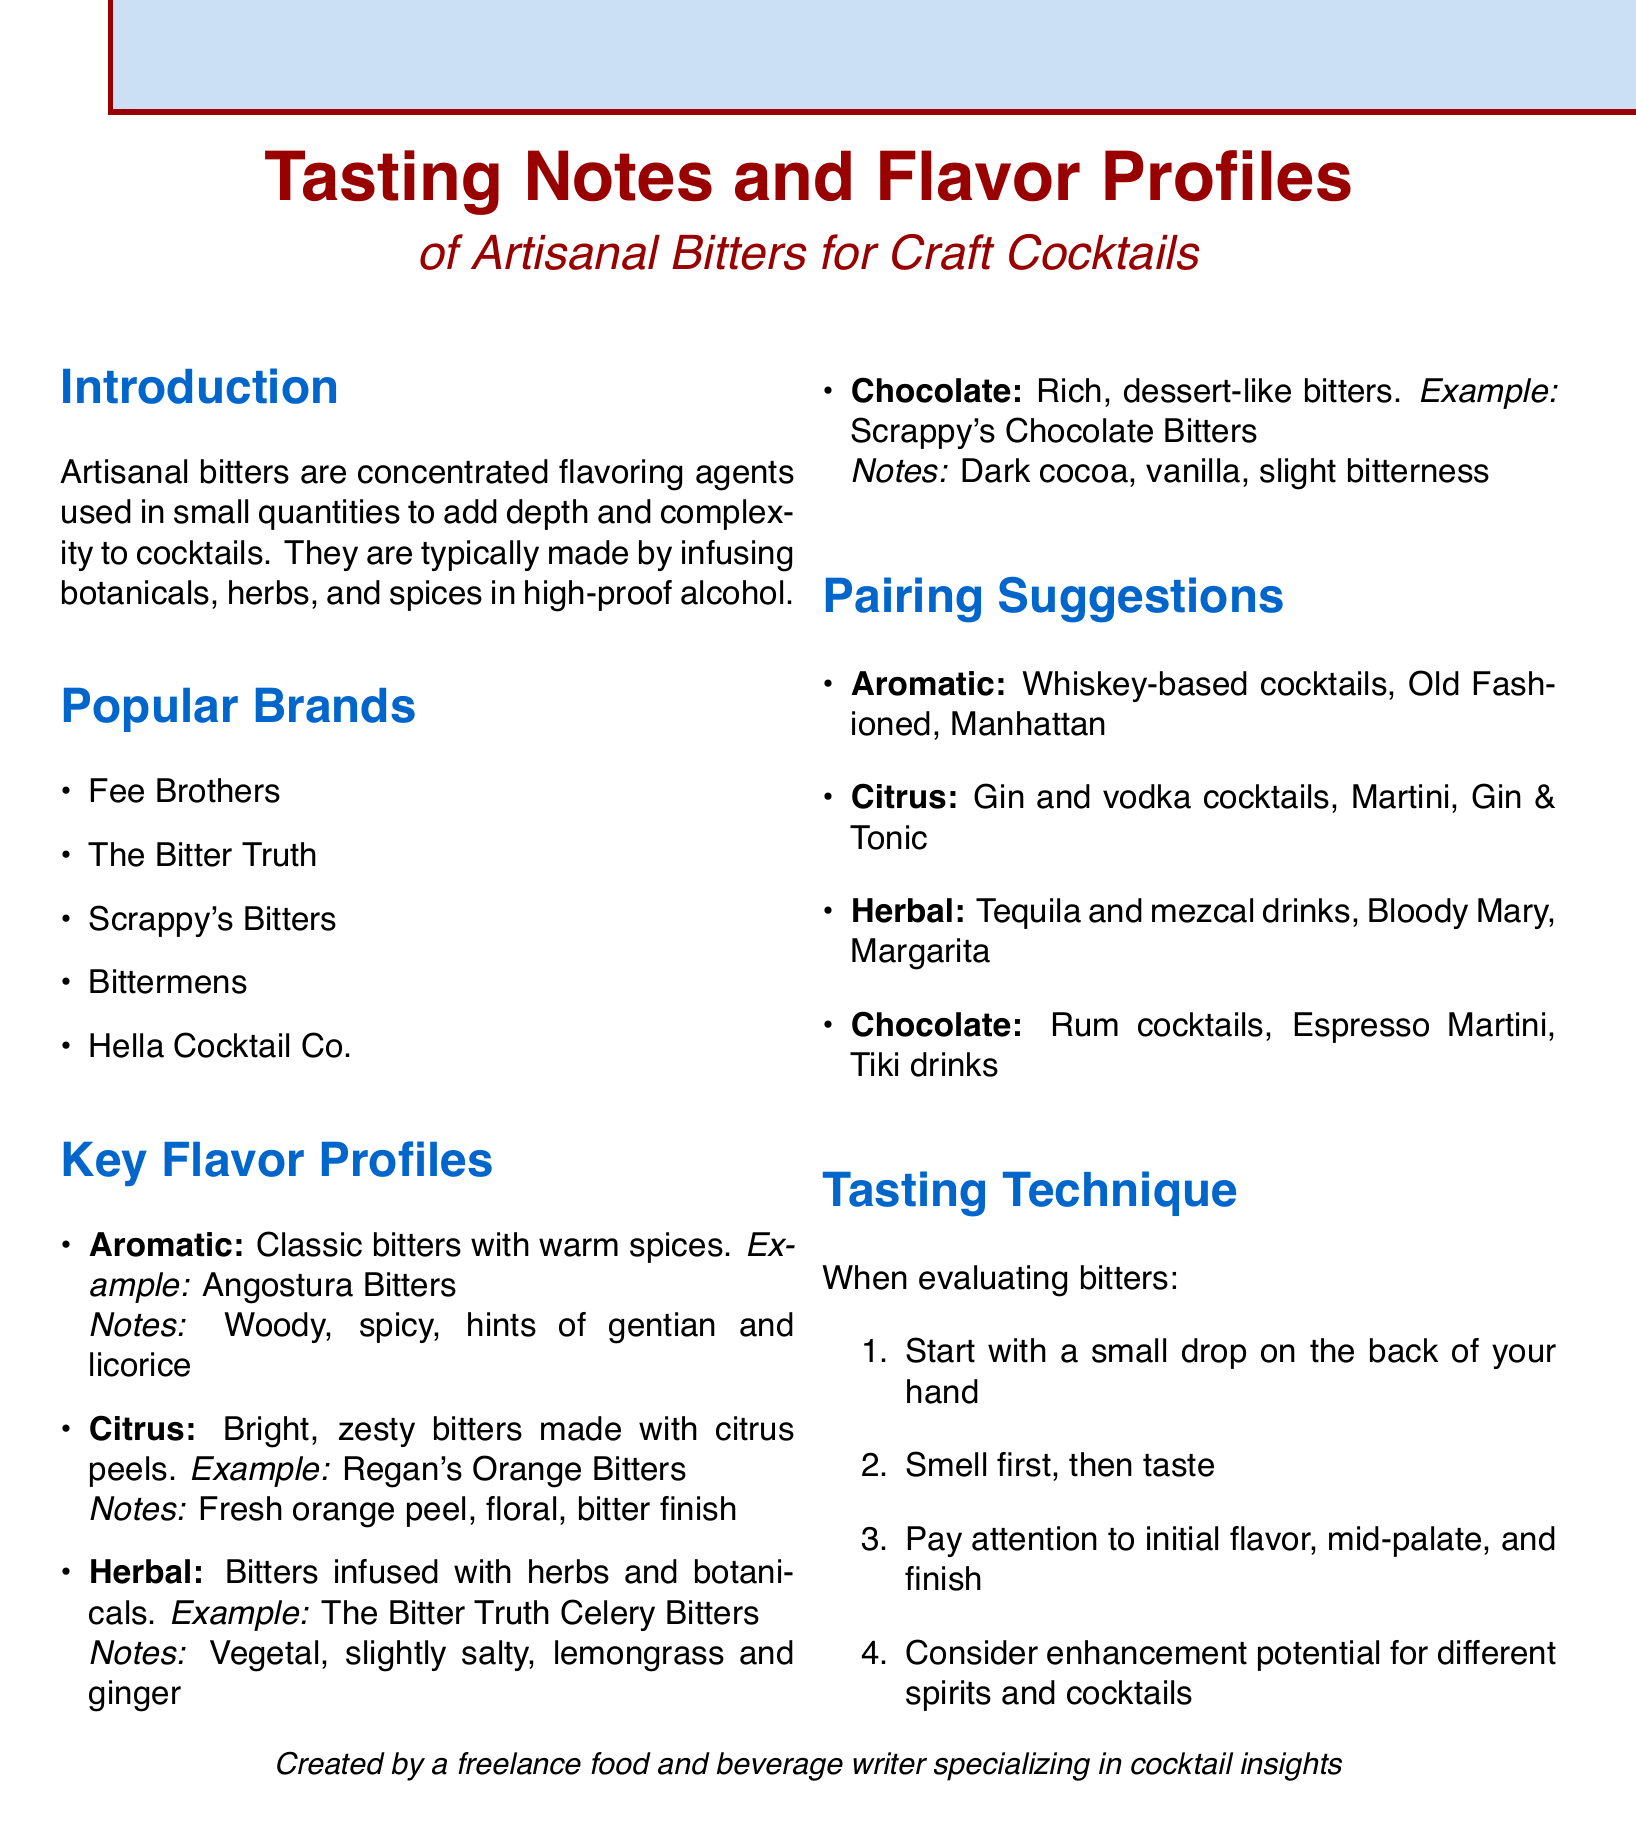What are artisanal bitters? Artisanal bitters are concentrated flavoring agents used in small quantities to add depth and complexity to cocktails, typically made by infusing botanicals, herbs, and spices in high-proof alcohol.
Answer: Concentrated flavoring agents Which brand is known for its chocolate bitters? The document lists Scrappy's Chocolate Bitters as an example of chocolate bitters.
Answer: Scrappy's What flavor profile features fresh orange peel? The flavor profile described with fresh orange peel is citrus.
Answer: Citrus Which cocktail pairing is suggested for herbal bitters? The document suggests tequila and mezcal drinks, such as Bloody Mary and Margarita, for herbal bitters.
Answer: Tequila and mezcal drinks How should bitters be evaluated according to the tasting technique? The tasting technique suggests starting with a small drop on the back of your hand, smelling first, then tasting, and paying attention to the initial flavor, mid-palate, and finish.
Answer: Small drop on the back of your hand What is an example of aromatic bitters? The document gives Angostura Bitters as an example of aromatic bitters.
Answer: Angostura Bitters What key tasting note is associated with chocolate bitters? The key tasting note associated with chocolate bitters is dark cocoa.
Answer: Dark cocoa Which type of bitters is paired with gin and vodka cocktails? Citrus bitters are suggested for pairing with gin and vodka cocktails.
Answer: Citrus bitters 